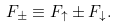Convert formula to latex. <formula><loc_0><loc_0><loc_500><loc_500>F _ { \pm } \equiv F _ { \uparrow } \pm F _ { \downarrow } .</formula> 